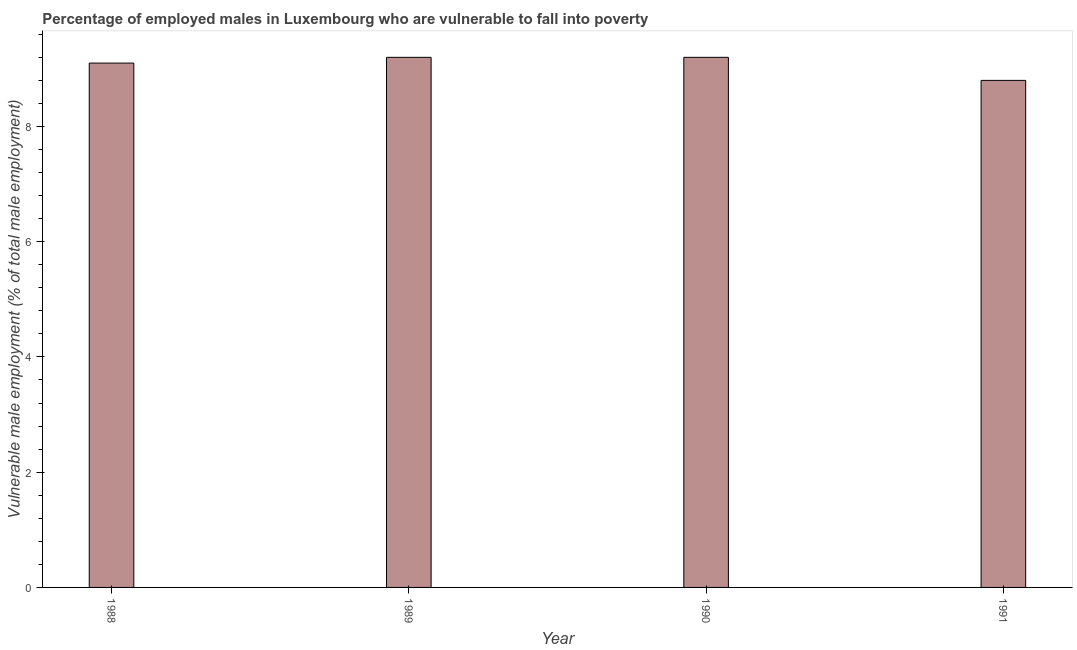What is the title of the graph?
Provide a succinct answer. Percentage of employed males in Luxembourg who are vulnerable to fall into poverty. What is the label or title of the Y-axis?
Offer a very short reply. Vulnerable male employment (% of total male employment). What is the percentage of employed males who are vulnerable to fall into poverty in 1989?
Make the answer very short. 9.2. Across all years, what is the maximum percentage of employed males who are vulnerable to fall into poverty?
Your answer should be very brief. 9.2. Across all years, what is the minimum percentage of employed males who are vulnerable to fall into poverty?
Your answer should be compact. 8.8. What is the sum of the percentage of employed males who are vulnerable to fall into poverty?
Your response must be concise. 36.3. What is the difference between the percentage of employed males who are vulnerable to fall into poverty in 1990 and 1991?
Offer a very short reply. 0.4. What is the average percentage of employed males who are vulnerable to fall into poverty per year?
Provide a short and direct response. 9.07. What is the median percentage of employed males who are vulnerable to fall into poverty?
Offer a very short reply. 9.15. Do a majority of the years between 1991 and 1989 (inclusive) have percentage of employed males who are vulnerable to fall into poverty greater than 1.2 %?
Ensure brevity in your answer.  Yes. Is the sum of the percentage of employed males who are vulnerable to fall into poverty in 1990 and 1991 greater than the maximum percentage of employed males who are vulnerable to fall into poverty across all years?
Offer a very short reply. Yes. What is the difference between the highest and the lowest percentage of employed males who are vulnerable to fall into poverty?
Offer a terse response. 0.4. In how many years, is the percentage of employed males who are vulnerable to fall into poverty greater than the average percentage of employed males who are vulnerable to fall into poverty taken over all years?
Make the answer very short. 3. How many bars are there?
Your answer should be compact. 4. Are all the bars in the graph horizontal?
Provide a succinct answer. No. What is the difference between two consecutive major ticks on the Y-axis?
Offer a very short reply. 2. What is the Vulnerable male employment (% of total male employment) of 1988?
Give a very brief answer. 9.1. What is the Vulnerable male employment (% of total male employment) in 1989?
Your answer should be very brief. 9.2. What is the Vulnerable male employment (% of total male employment) in 1990?
Make the answer very short. 9.2. What is the Vulnerable male employment (% of total male employment) in 1991?
Your answer should be compact. 8.8. What is the difference between the Vulnerable male employment (% of total male employment) in 1988 and 1989?
Offer a terse response. -0.1. What is the difference between the Vulnerable male employment (% of total male employment) in 1989 and 1990?
Make the answer very short. 0. What is the ratio of the Vulnerable male employment (% of total male employment) in 1988 to that in 1989?
Give a very brief answer. 0.99. What is the ratio of the Vulnerable male employment (% of total male employment) in 1988 to that in 1991?
Ensure brevity in your answer.  1.03. What is the ratio of the Vulnerable male employment (% of total male employment) in 1989 to that in 1990?
Give a very brief answer. 1. What is the ratio of the Vulnerable male employment (% of total male employment) in 1989 to that in 1991?
Ensure brevity in your answer.  1.04. What is the ratio of the Vulnerable male employment (% of total male employment) in 1990 to that in 1991?
Provide a short and direct response. 1.04. 